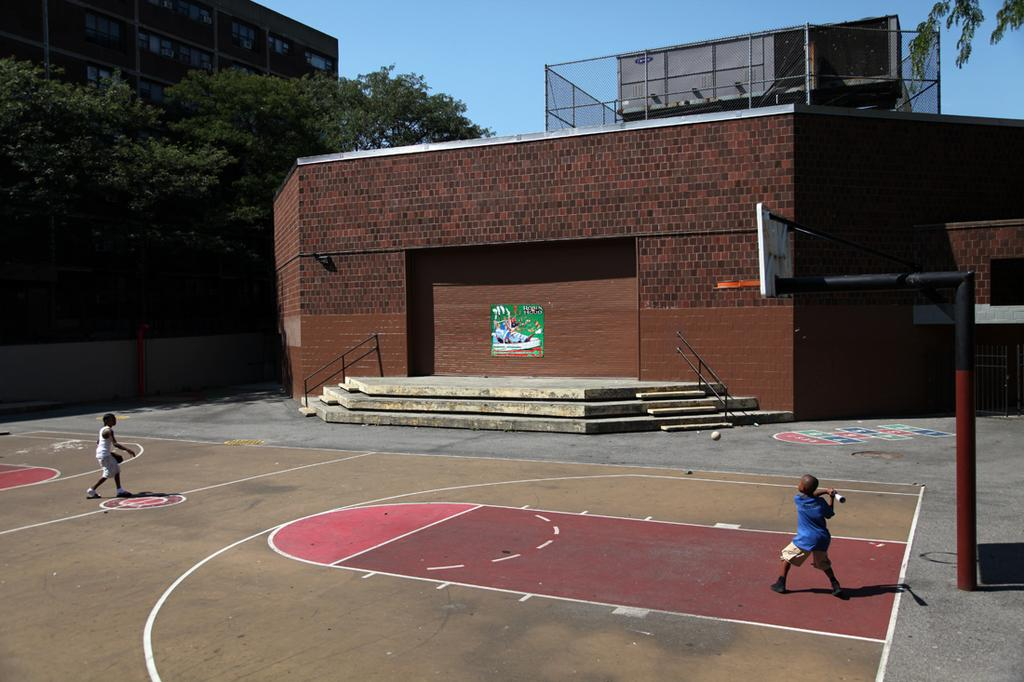What type of setting is depicted in the image? The image contains a basketball court. How many people are in the image? There are two people in the image. What can be seen in the background of the image? There is a wall in the background of the image. What is visible to the left of the image? Trees and a building are present to the left of the image. What type of clover is growing on the basketball court in the image? There is no clover present on the basketball court in the image. 